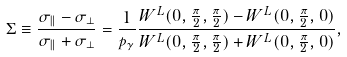<formula> <loc_0><loc_0><loc_500><loc_500>\Sigma \equiv \frac { \sigma _ { \| } - \sigma _ { \perp } } { \sigma _ { \| } + \sigma _ { \perp } } = \frac { 1 } { p _ { \gamma } } \frac { W ^ { L } ( 0 , \frac { \pi } { 2 } , \frac { \pi } { 2 } ) - W ^ { L } ( 0 , \frac { \pi } { 2 } , 0 ) } { W ^ { L } ( 0 , \frac { \pi } { 2 } , \frac { \pi } { 2 } ) + W ^ { L } ( 0 , \frac { \pi } { 2 } , 0 ) } ,</formula> 